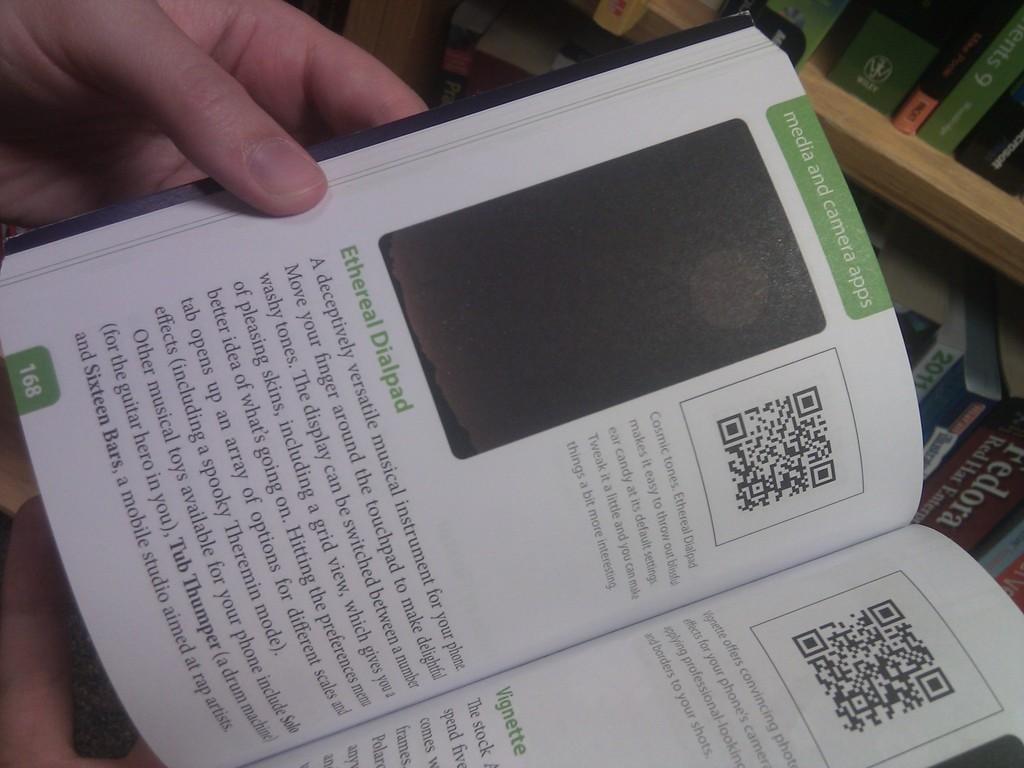<image>
Describe the image concisely. On page 168 is information on an Ethereal Dialpad for your phone. 